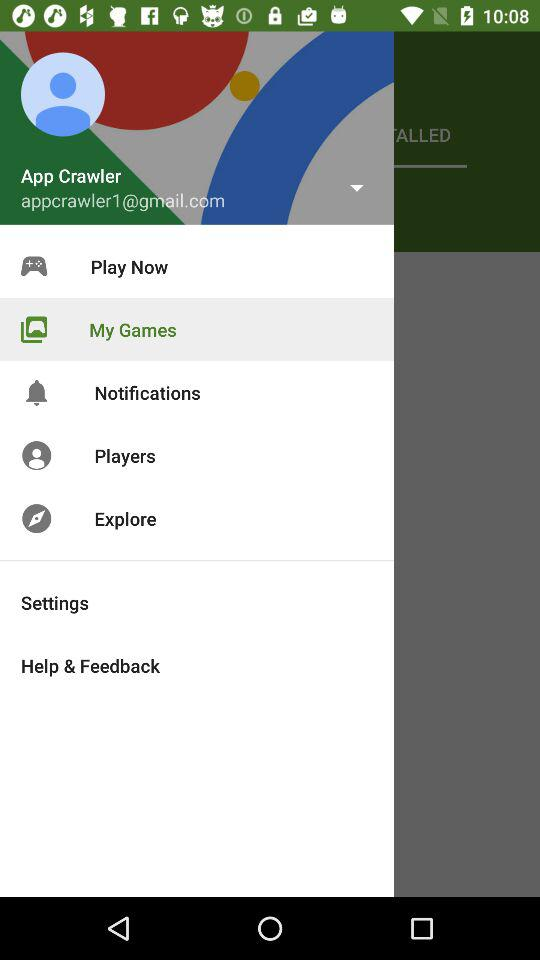Which option is selected? The selected option is "My Games". 